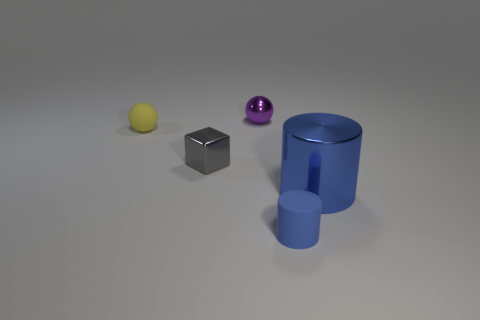Add 5 cylinders. How many objects exist? 10 Subtract all balls. How many objects are left? 3 Add 2 small blue cylinders. How many small blue cylinders exist? 3 Subtract 0 blue spheres. How many objects are left? 5 Subtract all red metal cubes. Subtract all blue metallic cylinders. How many objects are left? 4 Add 2 blue objects. How many blue objects are left? 4 